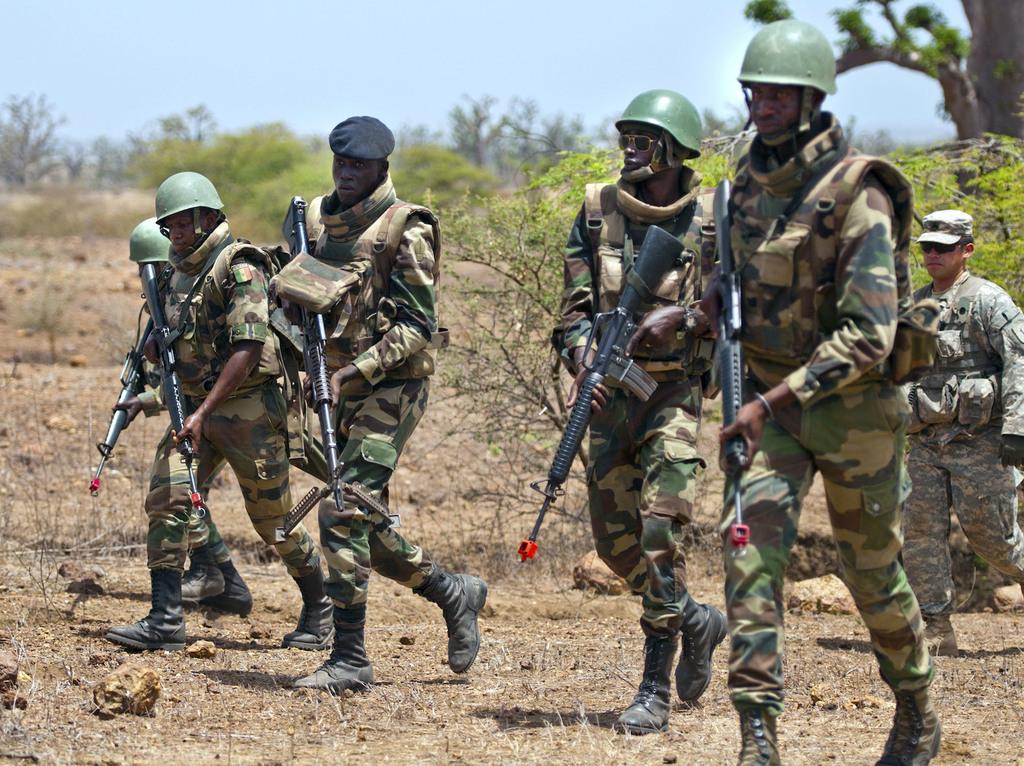Please provide a concise description of this image. In this image we can see a few military people wearing the uniforms and holding the guns and walking on the land. In the background we can see the trees. Sky is also visible. At the bottom we can see the dried grass. 